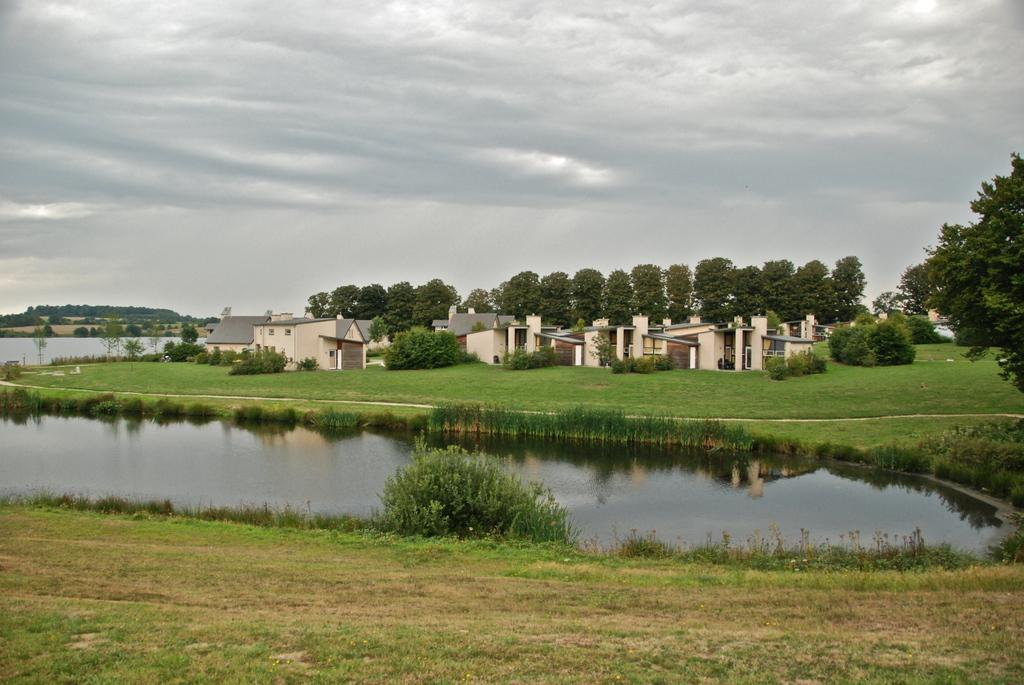What is the primary element visible in the image? There is water in the image. What type of vegetation can be seen on the ground? There is grass on the ground. What structures are visible in the background? There are buildings in the background. What type of natural elements are present in the background? There are trees in the background. What can be seen in the sky in the image? The sky is visible in the background with clouds. How many babies are participating in the exchange in the image? There is no exchange or babies present in the image. What part of the brain can be seen in the image? There is no brain visible in the image. 